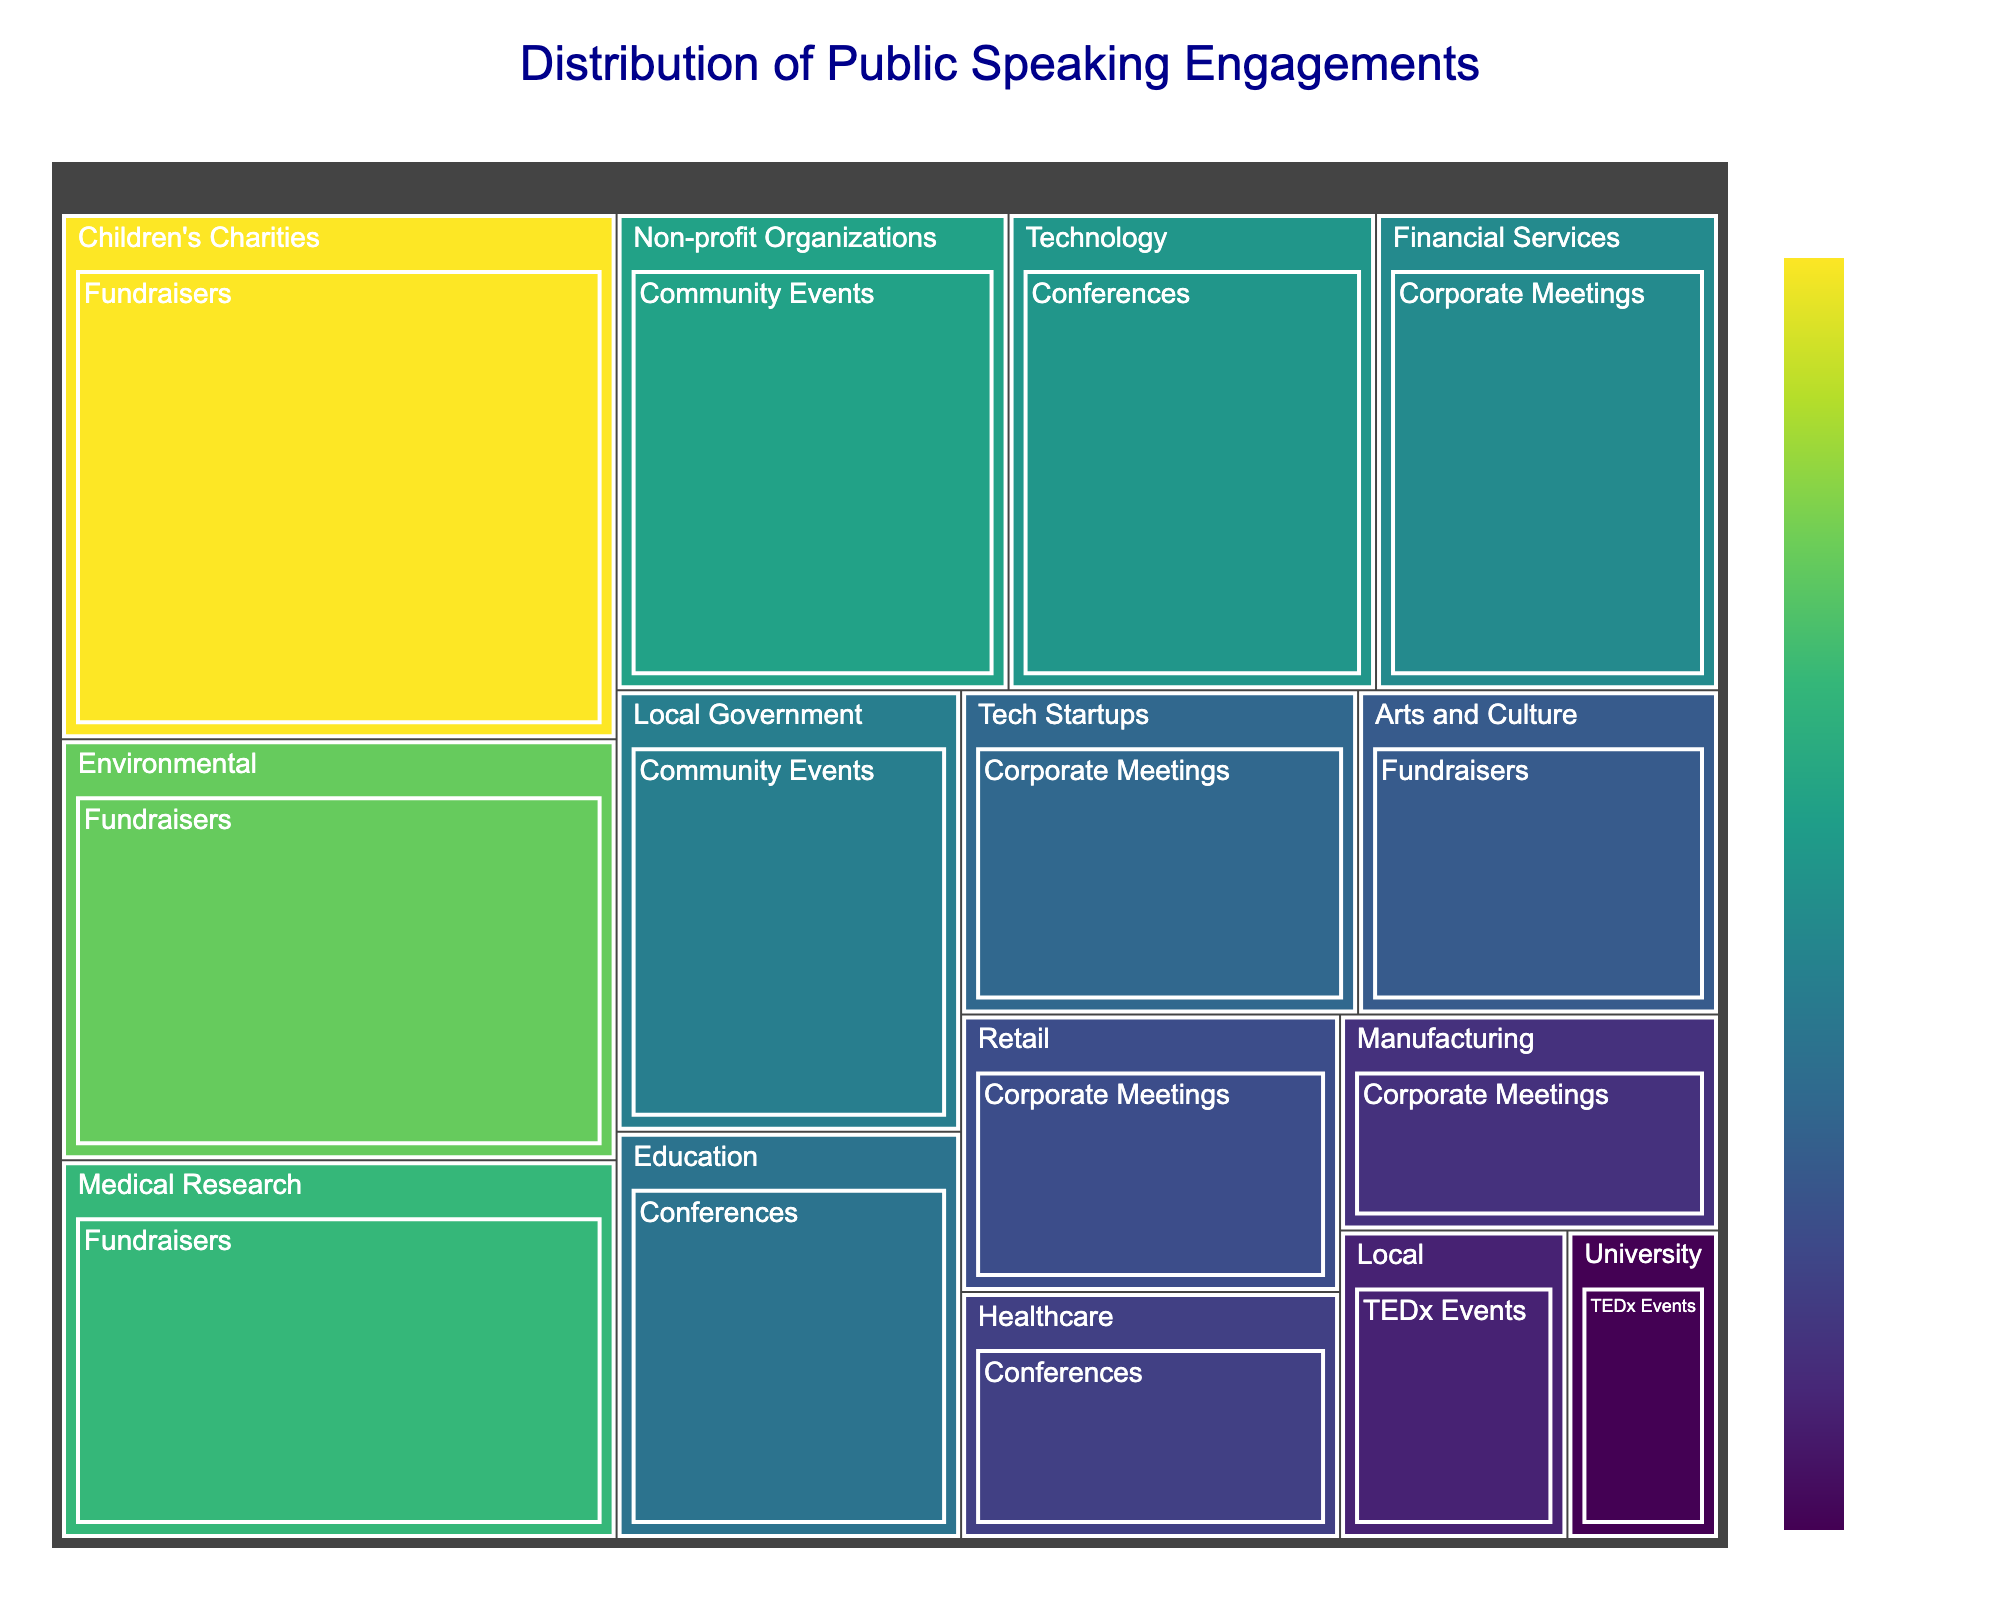What's the title of the figure? The title is usually located at the top of a chart and provides a summary of what the chart is about.
Answer: Distribution of Public Speaking Engagements Which event type has the highest number of engagements in the figure? By looking at the size of the rectangles and the number of engagements displayed, identify the event type with the largest rectangle.
Answer: Fundraisers How many engagements are there for Technology conferences? Find the rectangle labeled "Conferences" and then identify the sub-rectangle for "Technology". Read the number of engagements directly from the figure.
Answer: 15 What is the total number of speaking engagements for Corporate Meetings? Sum the number of engagements for all sub-categories under "Corporate Meetings": Financial Services (14) + Retail (9) + Manufacturing (7) + Tech Startups (11) = 41
Answer: 41 Which has more engagements: Environmental fundraisers or Medical Research fundraisers? Compare the number of engagements in the rectangles for "Environmental" and "Medical Research" under "Fundraisers".
Answer: Children's Charities How does the number of Healthcare conferences compare to the number of Non-profit Organization community events? Identify the number of engagements for Healthcare conferences (8) and Non-profit Organization community events (16). Compare which one is higher.
Answer: Non-profit Organizations Which category and event type combination has the smallest number of engagements? Look for the smallest rectangle and note its category and event type.
Answer: University TEDx Events How many total speaking engagements are there for TEDx Events? Add the number of engagements for both TEDx Event sub-categories: Local (6) + University (4) = 10
Answer: 10 What is the average number of engagements across all Fundraiser events? Add up all the number of engagements for Fundraisers (20 + 25 + 18 + 10) and then divide by the number of Fundraiser sub-categories (4): (20 + 25 + 18 + 10) / 4 = 18.25
Answer: 18.25 Is there a larger number of Technology conferences or Financial Services corporate meetings? Compare the engagements of Technology conferences (15) and Financial Services corporate meetings (14).
Answer: Technology Conferences 